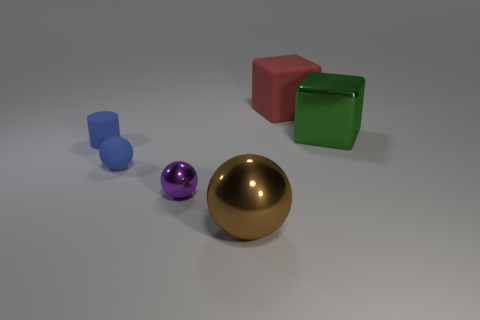Subtract all rubber spheres. How many spheres are left? 2 Subtract all green blocks. How many blocks are left? 1 Add 3 brown shiny balls. How many objects exist? 9 Subtract all cylinders. How many objects are left? 5 Add 3 blocks. How many blocks are left? 5 Add 1 cyan cylinders. How many cyan cylinders exist? 1 Subtract 1 red blocks. How many objects are left? 5 Subtract 1 spheres. How many spheres are left? 2 Subtract all yellow cylinders. Subtract all yellow cubes. How many cylinders are left? 1 Subtract all blue cylinders. How many purple blocks are left? 0 